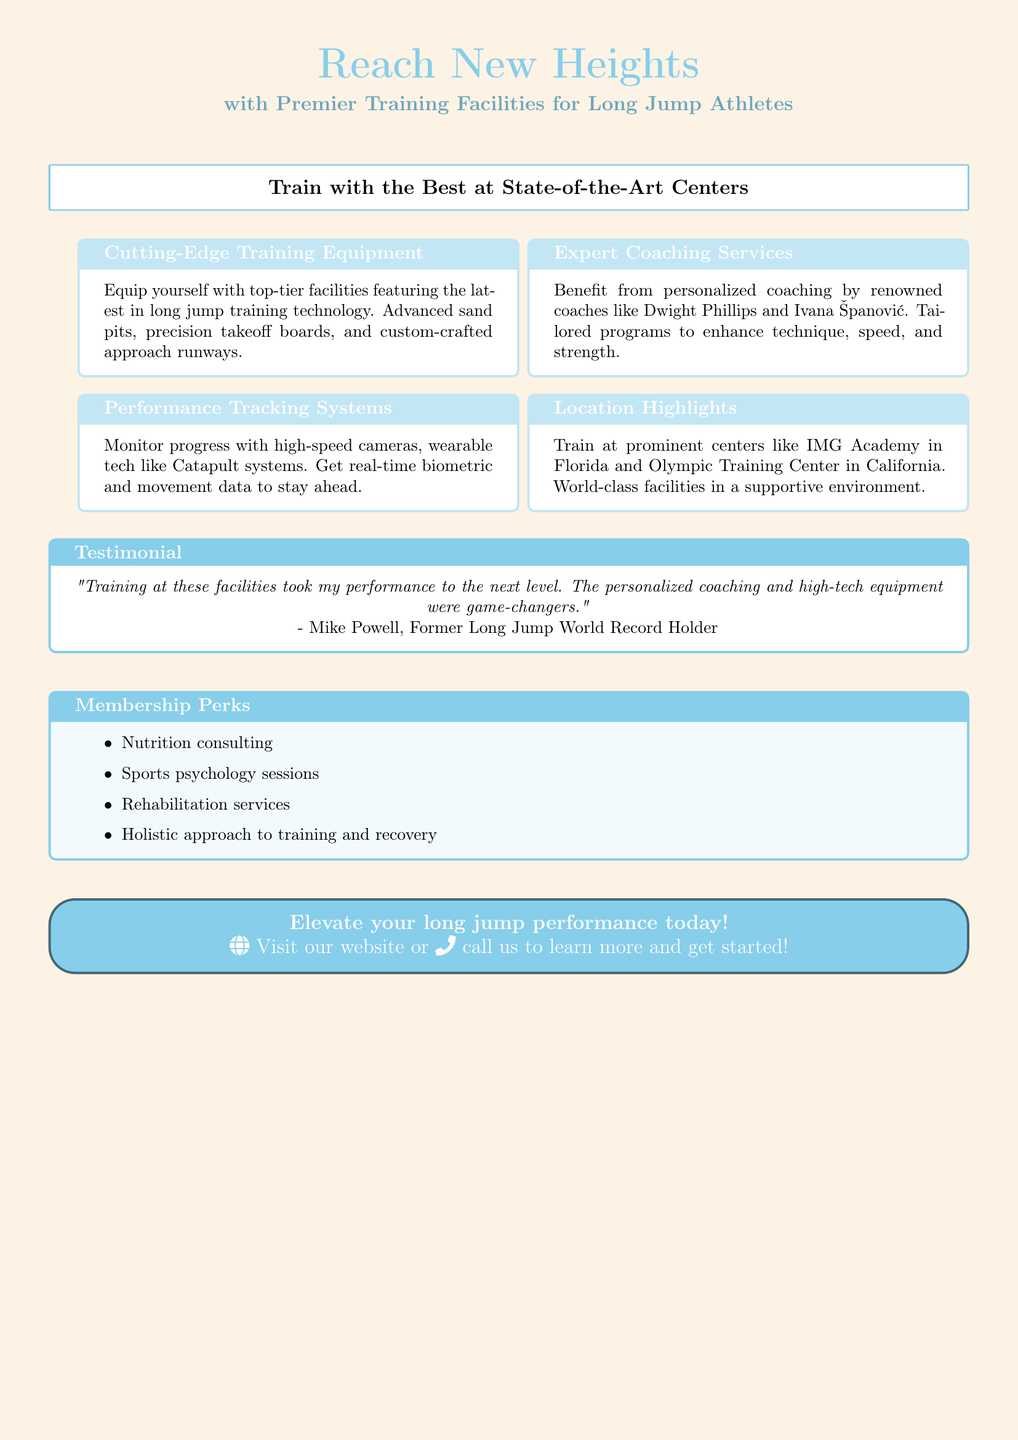What are the names of two renowned coaches mentioned? The advertisement highlights personalized coaching by renowned coaches, specifically naming Dwight Phillips and Ivana Španović.
Answer: Dwight Phillips and Ivana Španović What type of performance tracking technology is mentioned? The document specifies the use of high-speed cameras and wearable technology like Catapult systems as part of performance tracking.
Answer: High-speed cameras and Catapult systems Which facilities are specifically highlighted for training? The advertisement mentions training centers such as IMG Academy in Florida and the Olympic Training Center in California as prominent locations for long jump athletes.
Answer: IMG Academy and Olympic Training Center What is a benefit of the membership perks? The document lists various membership perks, including nutrition consulting and sports psychology sessions, which aid athletes in their training.
Answer: Nutrition consulting Who is quoted in the testimonial? The testimonial includes a quote from Mike Powell, a former long jump world record holder, emphasizing the impact of the facilities on performance.
Answer: Mike Powell What is emphasized about the approach to training? The advertisement highlights a holistic approach to training and recovery as a key aspect of their program for athletes, which includes various services.
Answer: Holistic approach 